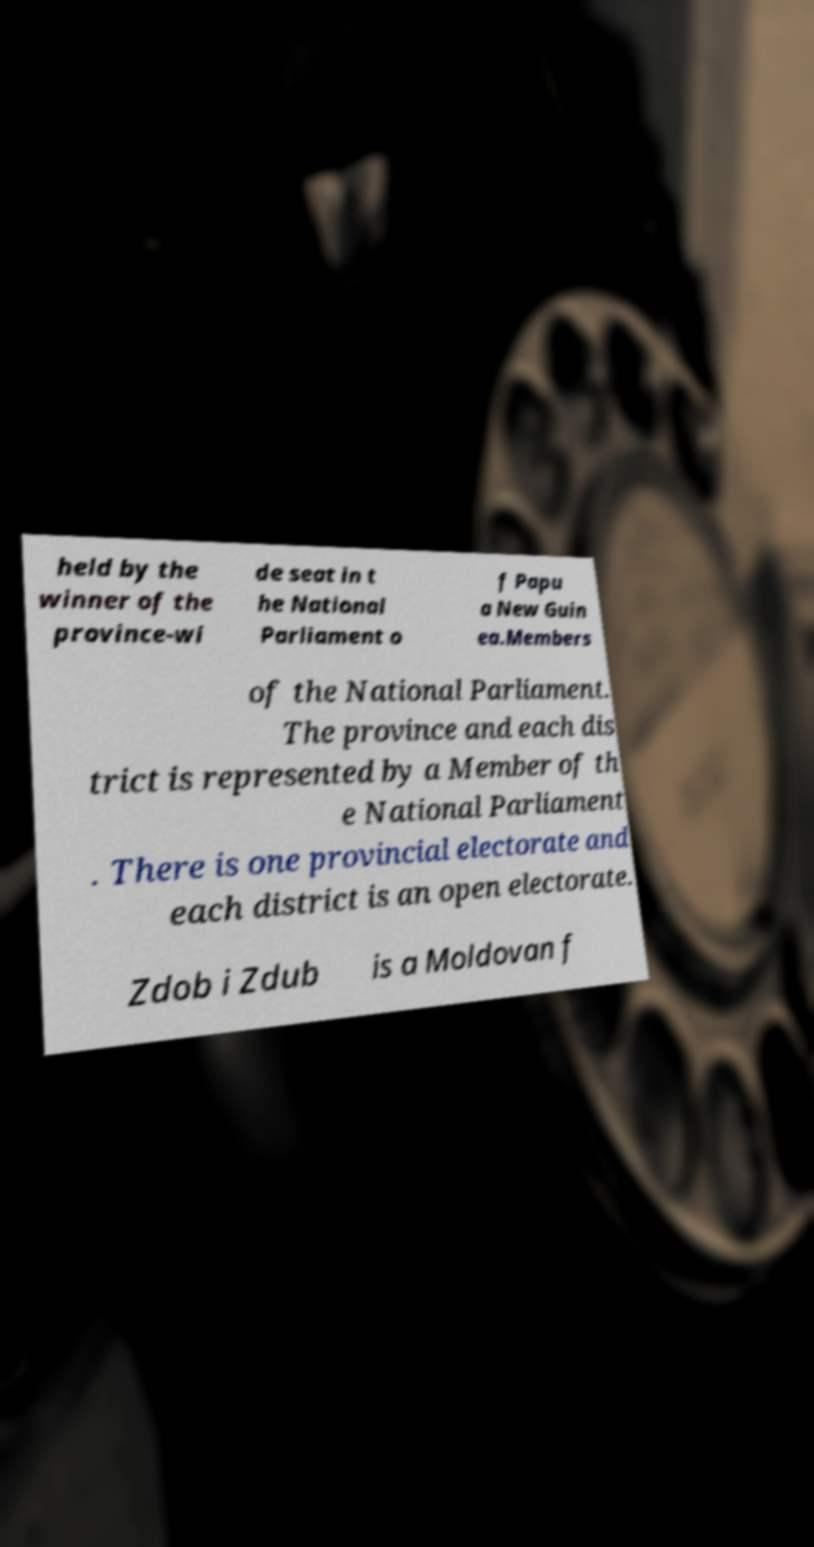For documentation purposes, I need the text within this image transcribed. Could you provide that? held by the winner of the province-wi de seat in t he National Parliament o f Papu a New Guin ea.Members of the National Parliament. The province and each dis trict is represented by a Member of th e National Parliament . There is one provincial electorate and each district is an open electorate. Zdob i Zdub is a Moldovan f 